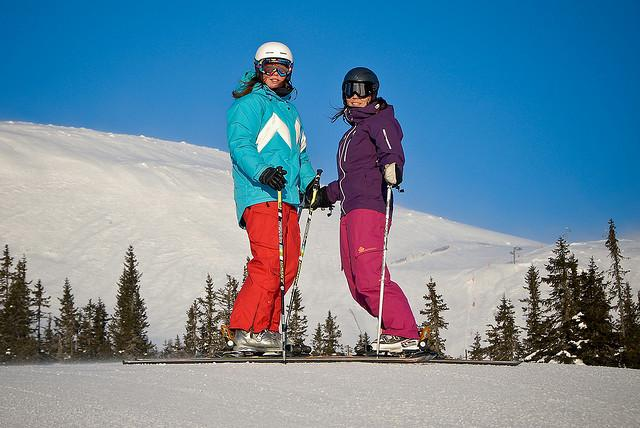What's the weather like for these skiers? Please explain your reasoning. clear. There is not a cloud in the sky. 